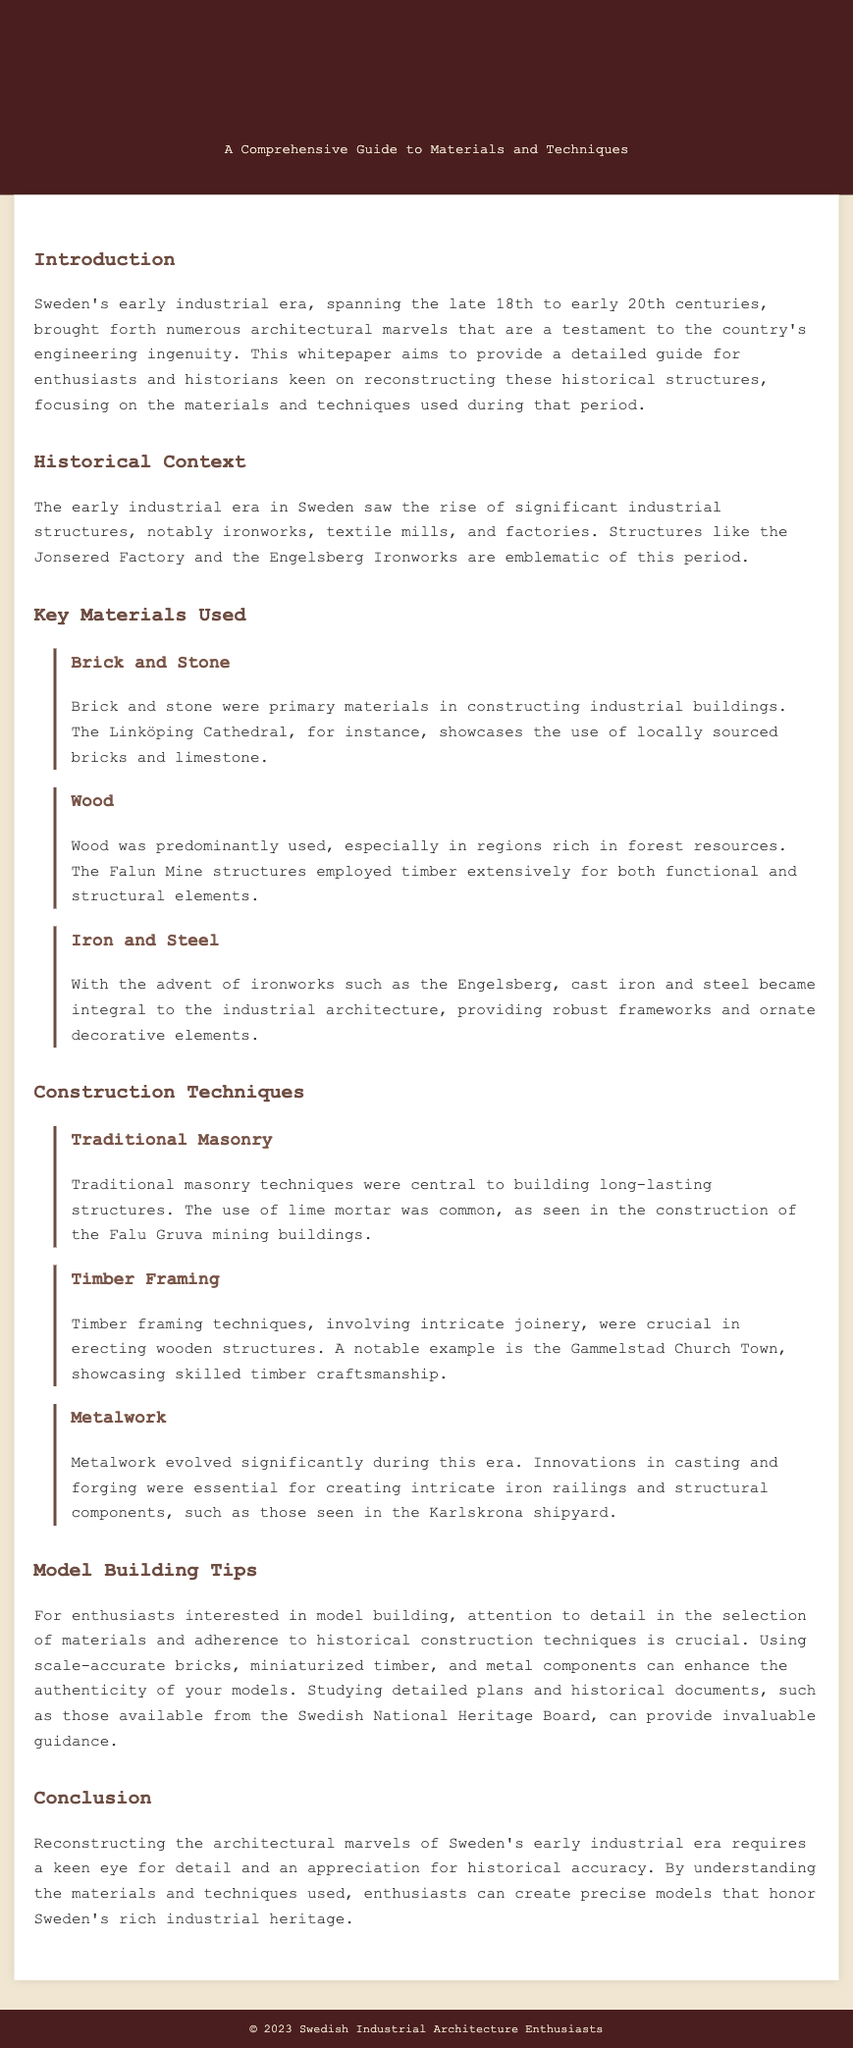What is the primary focus of this whitepaper? The primary focus of the whitepaper is to provide a detailed guide for enthusiasts and historians keen on reconstructing historical structures, focusing on materials and techniques used during Sweden's early industrial era.
Answer: Reconstructing historical structures Which era does the whitepaper cover? The whitepaper covers Sweden's early industrial era, which spans the late 18th to early 20th centuries.
Answer: Late 18th to early 20th centuries What is a notable example of an industrial structure mentioned in the document? The document mentions the Jonsered Factory as a notable example of an industrial structure from the early industrial era.
Answer: Jonsered Factory What material was predominantly used in regions rich in forest resources? The material predominantly used in such regions is wood, as noted in the document.
Answer: Wood Which construction technique involves intricate joinery? The construction technique that involves intricate joinery is timber framing.
Answer: Timber framing What is a key tip for model building enthusiasts? A key tip stated in the document is to pay attention to detail in the selection of materials and adherence to historical construction techniques.
Answer: Attention to detail Which mining buildings utilize lime mortar? The mining buildings that utilize lime mortar are those of the Falu Gruva, as mentioned in the paper.
Answer: Falu Gruva What innovative techniques evolved significantly during the industrial era? The innovative techniques that evolved significantly are casting and forging, essential for metalwork.
Answer: Casting and forging 